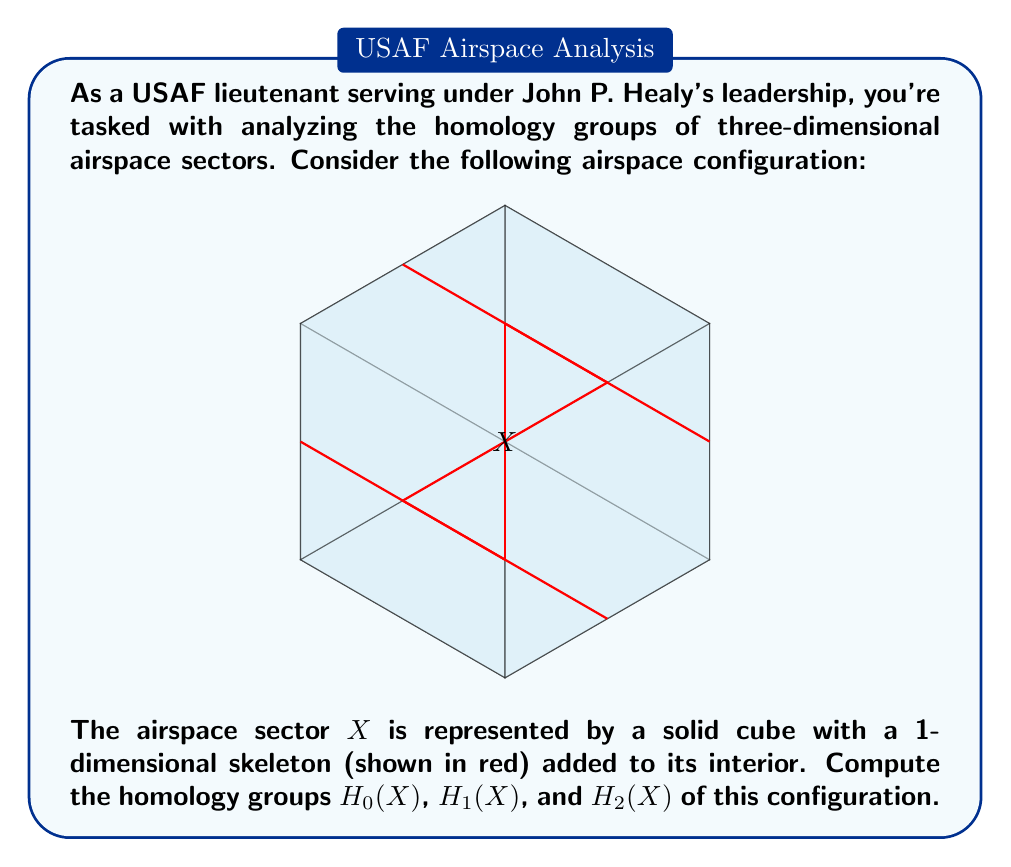Provide a solution to this math problem. Let's approach this step-by-step:

1) First, we need to understand what the space $X$ represents. It's a solid cube with additional 1-dimensional structures inside, forming a "cross" in the cube's interior.

2) To compute the homology groups, we'll use the fact that homology is a homotopy invariant. This means we can deformation retract our space to a simpler one without changing its homology groups.

3) The solid cube can be retracted to its boundary (a 2-sphere $S^2$) plus the interior 1-dimensional skeleton.

4) The interior 1-dimensional skeleton forms three line segments that intersect at the center of the cube. This is homotopy equivalent to a bouquet of three circles.

5) So, our space $X$ is homotopy equivalent to $S^2 \vee S^1 \vee S^1 \vee S^1$ (a wedge sum of a 2-sphere and three 1-spheres).

6) Now, let's compute the homology groups:

   a) $H_0(X)$: This counts the number of path-connected components. Our space is connected, so $H_0(X) \cong \mathbb{Z}$.

   b) $H_1(X)$: This corresponds to the 1-dimensional "holes" in our space. Each $S^1$ in the wedge sum contributes one generator to $H_1$. Therefore, $H_1(X) \cong \mathbb{Z} \oplus \mathbb{Z} \oplus \mathbb{Z}$.

   c) $H_2(X)$: This corresponds to 2-dimensional "voids" in our space. The $S^2$ contributes one generator to $H_2$. Therefore, $H_2(X) \cong \mathbb{Z}$.

   d) $H_n(X)$ for $n \geq 3$: These are all trivial (zero) because our space has no higher-dimensional features.

7) Thus, we have computed all non-trivial homology groups of $X$.
Answer: $H_0(X) \cong \mathbb{Z}$, $H_1(X) \cong \mathbb{Z}^3$, $H_2(X) \cong \mathbb{Z}$, $H_n(X) \cong 0$ for $n \geq 3$ 